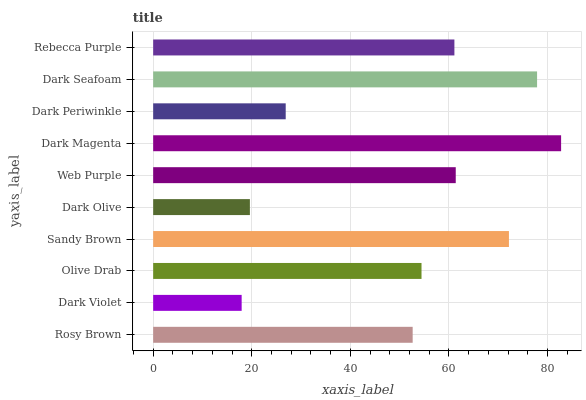Is Dark Violet the minimum?
Answer yes or no. Yes. Is Dark Magenta the maximum?
Answer yes or no. Yes. Is Olive Drab the minimum?
Answer yes or no. No. Is Olive Drab the maximum?
Answer yes or no. No. Is Olive Drab greater than Dark Violet?
Answer yes or no. Yes. Is Dark Violet less than Olive Drab?
Answer yes or no. Yes. Is Dark Violet greater than Olive Drab?
Answer yes or no. No. Is Olive Drab less than Dark Violet?
Answer yes or no. No. Is Rebecca Purple the high median?
Answer yes or no. Yes. Is Olive Drab the low median?
Answer yes or no. Yes. Is Web Purple the high median?
Answer yes or no. No. Is Rosy Brown the low median?
Answer yes or no. No. 